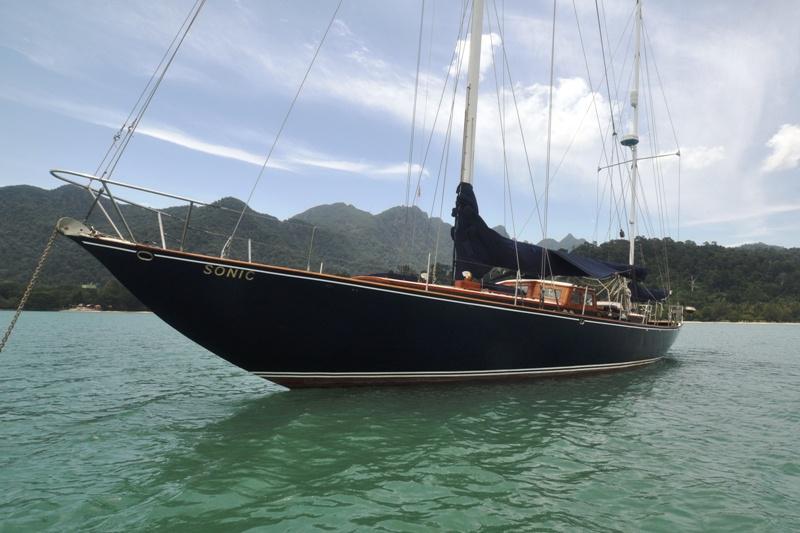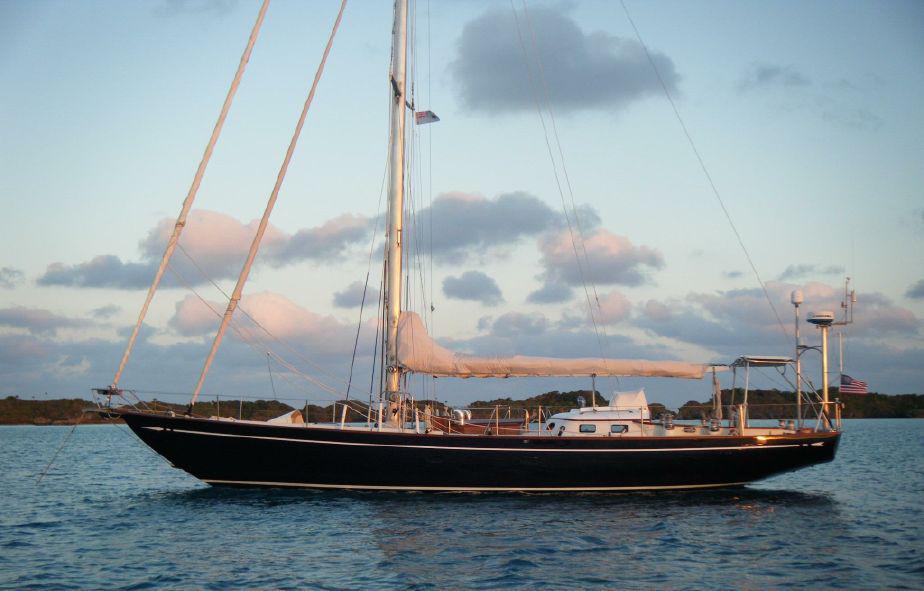The first image is the image on the left, the second image is the image on the right. Analyze the images presented: Is the assertion "All images show white-bodied boats, and no boat has its sails unfurled." valid? Answer yes or no. No. The first image is the image on the left, the second image is the image on the right. Evaluate the accuracy of this statement regarding the images: "Both sailboats have furled white sails.". Is it true? Answer yes or no. No. 